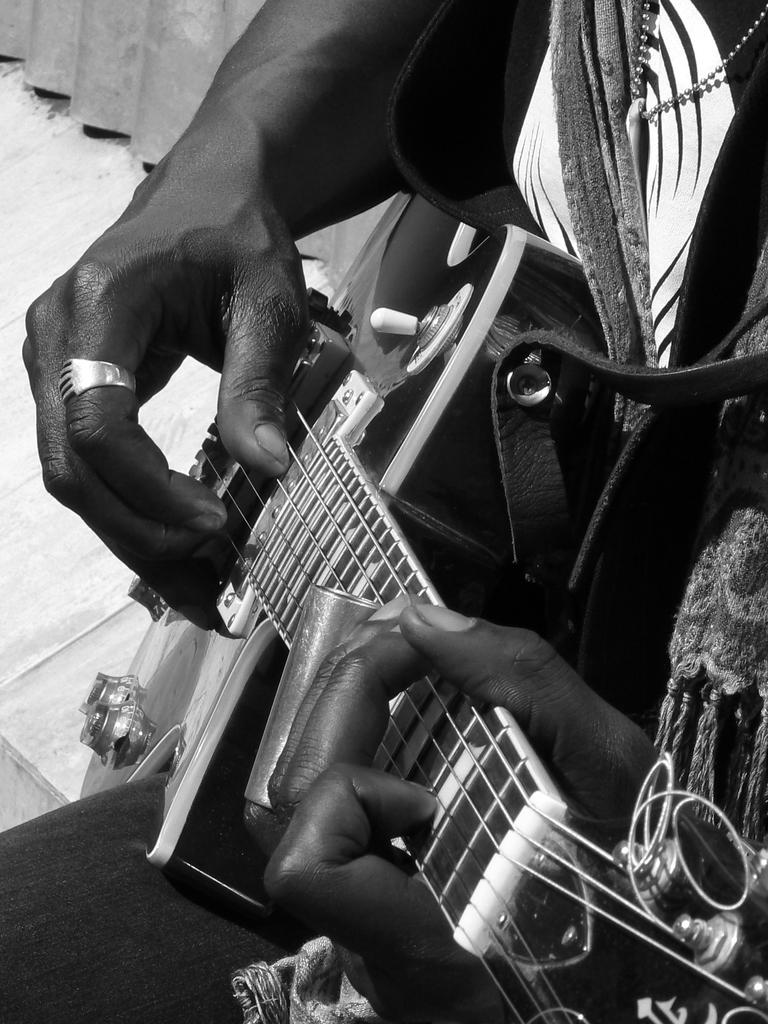What body part is visible in the image? There are hands visible in the image. Whose hands are these? The hands belong to a person. What is the person doing with their hands? The person is playing a guitar. How does the person adjust the alley while playing the guitar in the image? There is no alley present in the image, and the person is not adjusting anything related to an alley while playing the guitar. 